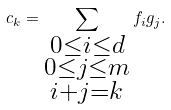<formula> <loc_0><loc_0><loc_500><loc_500>c _ { k } = \sum _ { \substack { 0 \leq i \leq d \\ 0 \leq j \leq m \\ i + j = k } } f _ { i } g _ { j } .</formula> 